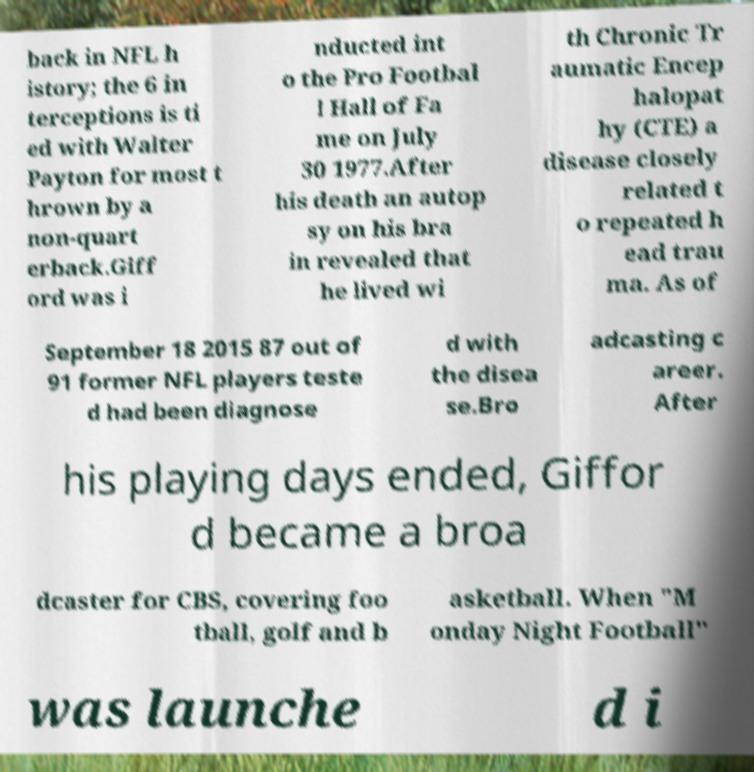Please read and relay the text visible in this image. What does it say? back in NFL h istory; the 6 in terceptions is ti ed with Walter Payton for most t hrown by a non-quart erback.Giff ord was i nducted int o the Pro Footbal l Hall of Fa me on July 30 1977.After his death an autop sy on his bra in revealed that he lived wi th Chronic Tr aumatic Encep halopat hy (CTE) a disease closely related t o repeated h ead trau ma. As of September 18 2015 87 out of 91 former NFL players teste d had been diagnose d with the disea se.Bro adcasting c areer. After his playing days ended, Giffor d became a broa dcaster for CBS, covering foo tball, golf and b asketball. When "M onday Night Football" was launche d i 